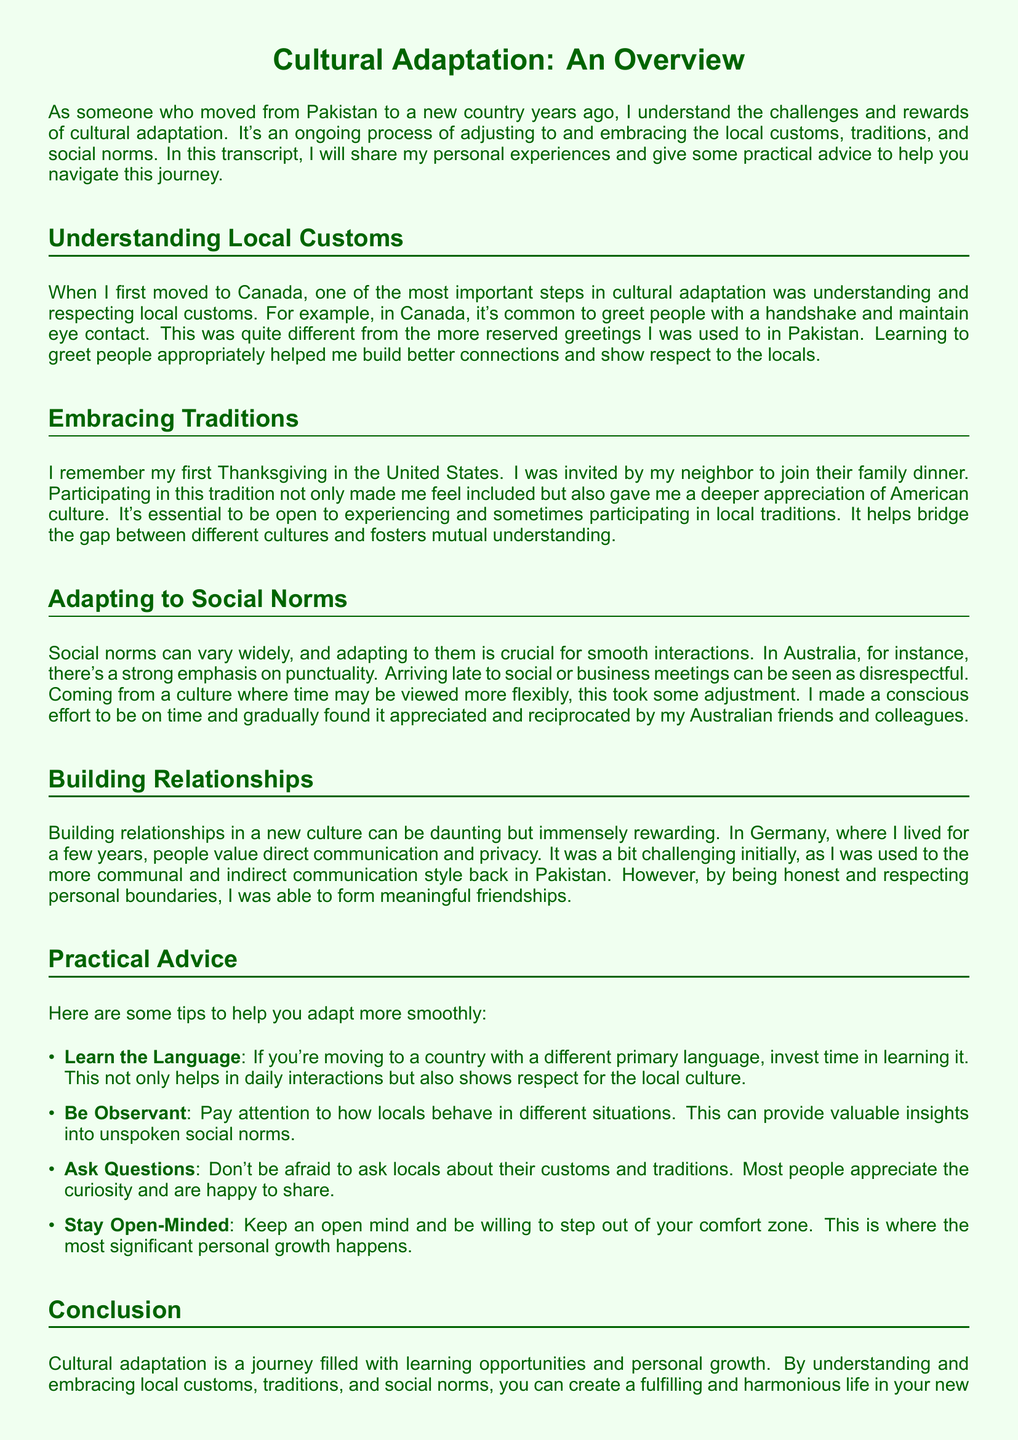What is the title of the document? The title of the document is presented in the center at the beginning and clearly states the focus of the content.
Answer: Cultural Adaptation: An Overview What country did the author move to from Pakistan? The author mentions several countries but specifically highlights their adaptation experiences in Canada, the United States, Australia, and Germany.
Answer: Canada Which local custom did the author emphasize when greeting people in Canada? The author describes a common practice in Canada that signifies polite communication and respect, which contrasts with their previous experiences.
Answer: Handshake and maintaining eye contact What tradition did the author participate in during their first year in the United States? The author shares a personal story about a significant cultural celebration that helped them feel included in the local community.
Answer: Thanksgiving What social norm was the author required to adapt to in Australia? The author reflects on a local expectation that can impact social interactions, particularly in professional settings.
Answer: Punctuality Which country did the author mention that values direct communication? The author highlights a cultural characteristic of a country where they lived, which differs from their upbringing in Pakistan.
Answer: Germany What is one piece of practical advice given in the document? The author lists multiple strategies for adapting to new cultures, which can effectively enhance the integration experience.
Answer: Learn the Language How many practical advice points are listed in the document? The document provides a structured list of actionable strategies, which can be easily counted for clarity.
Answer: Four 